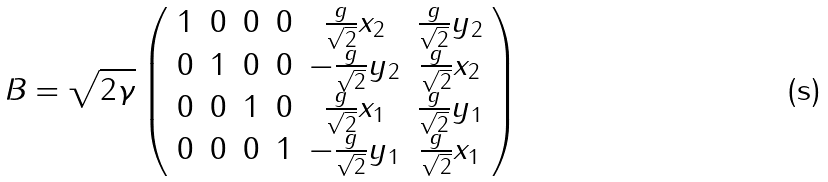Convert formula to latex. <formula><loc_0><loc_0><loc_500><loc_500>B = \sqrt { 2 \gamma } \left ( \begin{array} { c c c c c c } 1 & 0 & 0 & 0 & \frac { g } { \sqrt { 2 } } x _ { 2 } & \frac { g } { \sqrt { 2 } } y _ { 2 } \\ 0 & 1 & 0 & 0 & - \frac { g } { \sqrt { 2 } } y _ { 2 } & \frac { g } { \sqrt { 2 } } x _ { 2 } \\ 0 & 0 & 1 & 0 & \frac { g } { \sqrt { 2 } } x _ { 1 } & \frac { g } { \sqrt { 2 } } y _ { 1 } \\ 0 & 0 & 0 & 1 & - \frac { g } { \sqrt { 2 } } y _ { 1 } & \frac { g } { \sqrt { 2 } } x _ { 1 } \\ \end{array} \right )</formula> 